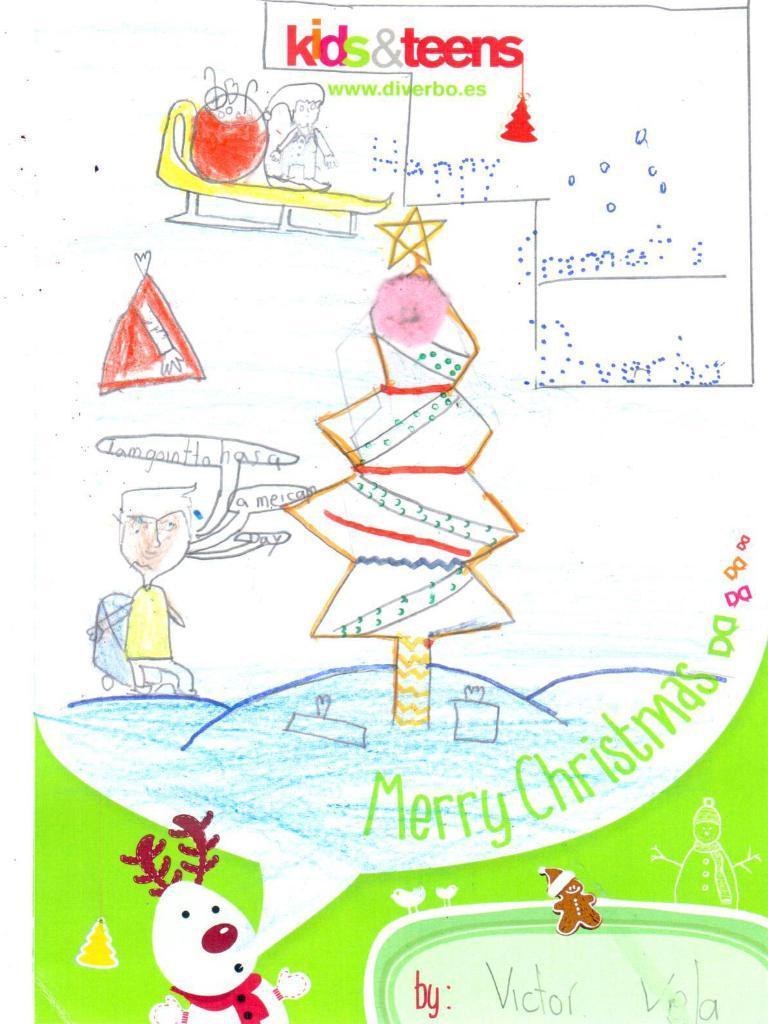In one or two sentences, can you explain what this image depicts? In this picture we can see a drawing and in this drawing we can see two people, snowman, tree, some objects and some text. 